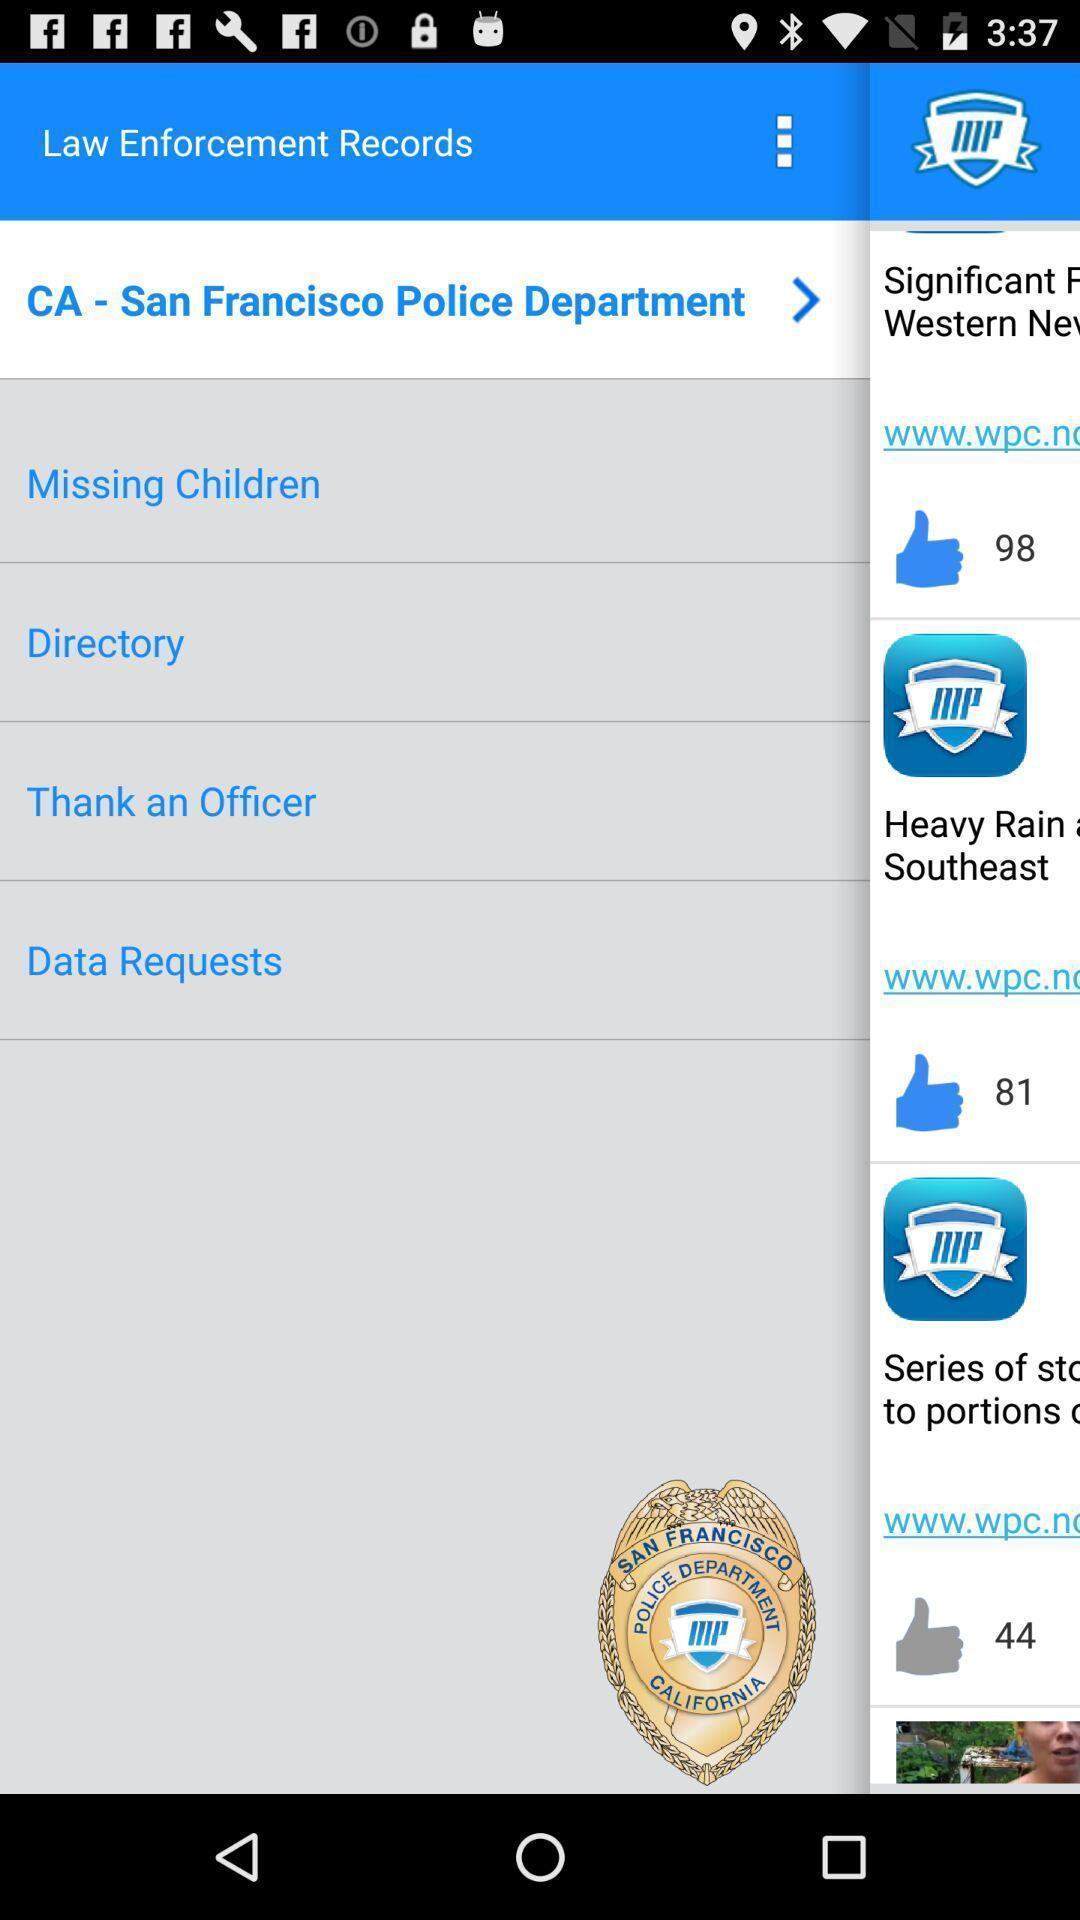Describe this image in words. Screen showing list of various records. 